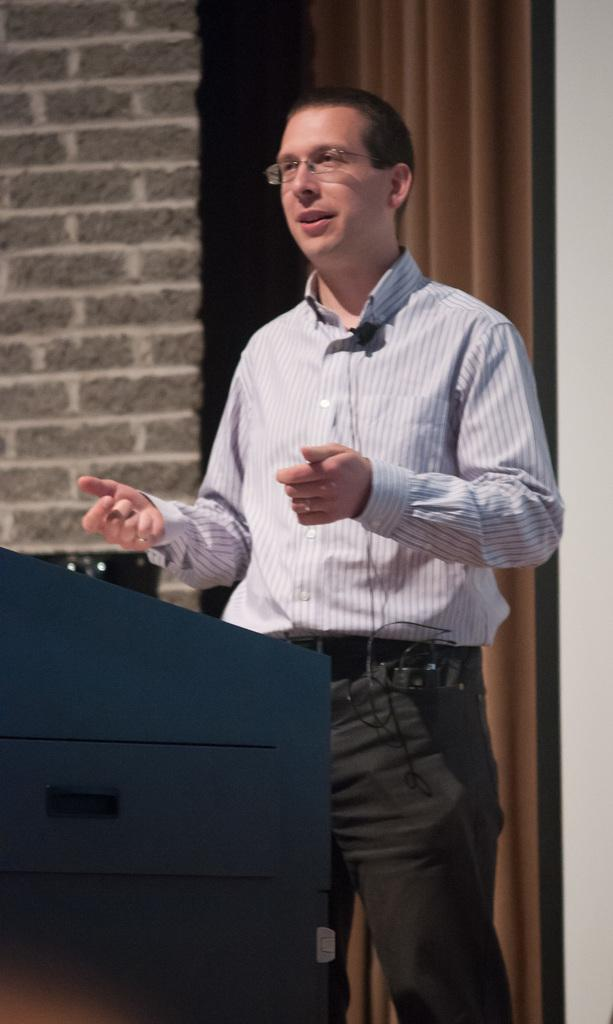What is the main subject of the image? There is a man in the image. What is the man doing in the image? The man appears to be explaining something. What is in front of the man? There is a podium in front of the man. What can be seen in the background of the image? There is a curtain in the background of the image, and a wall behind the man. What type of stamp can be seen on the man's flesh in the image? There is no stamp visible on the man's flesh in the image. How many beds are present in the image? There are no beds present in the image. 